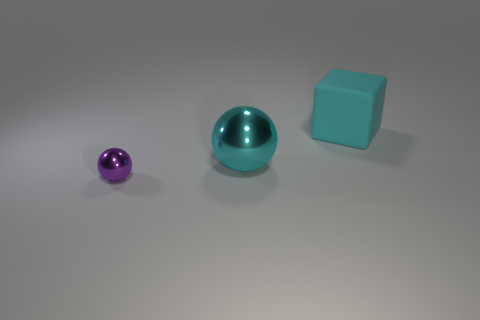Is the color of the big metallic sphere in front of the matte object the same as the large thing to the right of the large cyan metal ball?
Provide a succinct answer. Yes. Do the big object on the left side of the big rubber object and the tiny sphere in front of the cyan matte cube have the same material?
Give a very brief answer. Yes. How many shiny objects are either large cyan spheres or large cubes?
Make the answer very short. 1. There is a tiny ball that is to the left of the sphere behind the sphere in front of the big metal ball; what is its material?
Provide a succinct answer. Metal. There is a metal thing in front of the cyan metal ball; does it have the same shape as the cyan object left of the cyan rubber thing?
Make the answer very short. Yes. There is a shiny object right of the object in front of the big metallic sphere; what is its color?
Offer a terse response. Cyan. How many spheres are cyan metal things or large things?
Offer a terse response. 1. There is a big thing that is to the left of the large thing to the right of the big metallic sphere; what number of tiny metal balls are on the left side of it?
Provide a short and direct response. 1. Are there any small purple balls made of the same material as the tiny purple object?
Give a very brief answer. No. Does the big cyan ball have the same material as the large cyan cube?
Your answer should be very brief. No. 